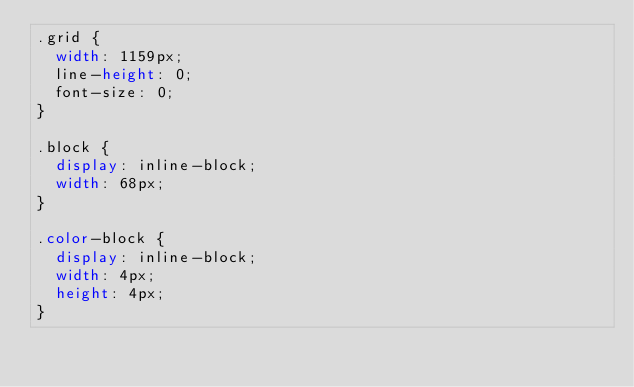Convert code to text. <code><loc_0><loc_0><loc_500><loc_500><_CSS_>.grid {
  width: 1159px;
  line-height: 0;
  font-size: 0;
}

.block {
  display: inline-block;
  width: 68px;
}

.color-block {
  display: inline-block;
  width: 4px;
  height: 4px;
}
</code> 